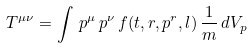<formula> <loc_0><loc_0><loc_500><loc_500>T ^ { \mu \nu } = \int \, p ^ { \mu } \, p ^ { \nu } \, f ( t , r , p ^ { r } , l ) \, \frac { 1 } { m } \, d V _ { p }</formula> 